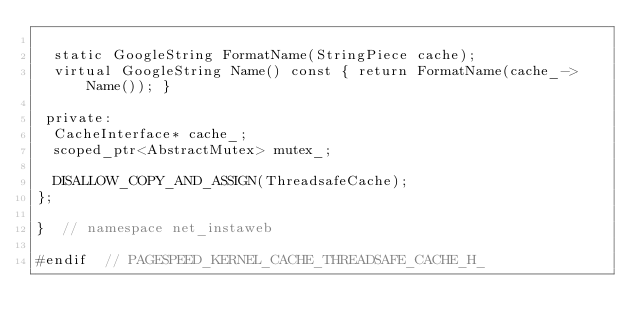Convert code to text. <code><loc_0><loc_0><loc_500><loc_500><_C_>
  static GoogleString FormatName(StringPiece cache);
  virtual GoogleString Name() const { return FormatName(cache_->Name()); }

 private:
  CacheInterface* cache_;
  scoped_ptr<AbstractMutex> mutex_;

  DISALLOW_COPY_AND_ASSIGN(ThreadsafeCache);
};

}  // namespace net_instaweb

#endif  // PAGESPEED_KERNEL_CACHE_THREADSAFE_CACHE_H_
</code> 